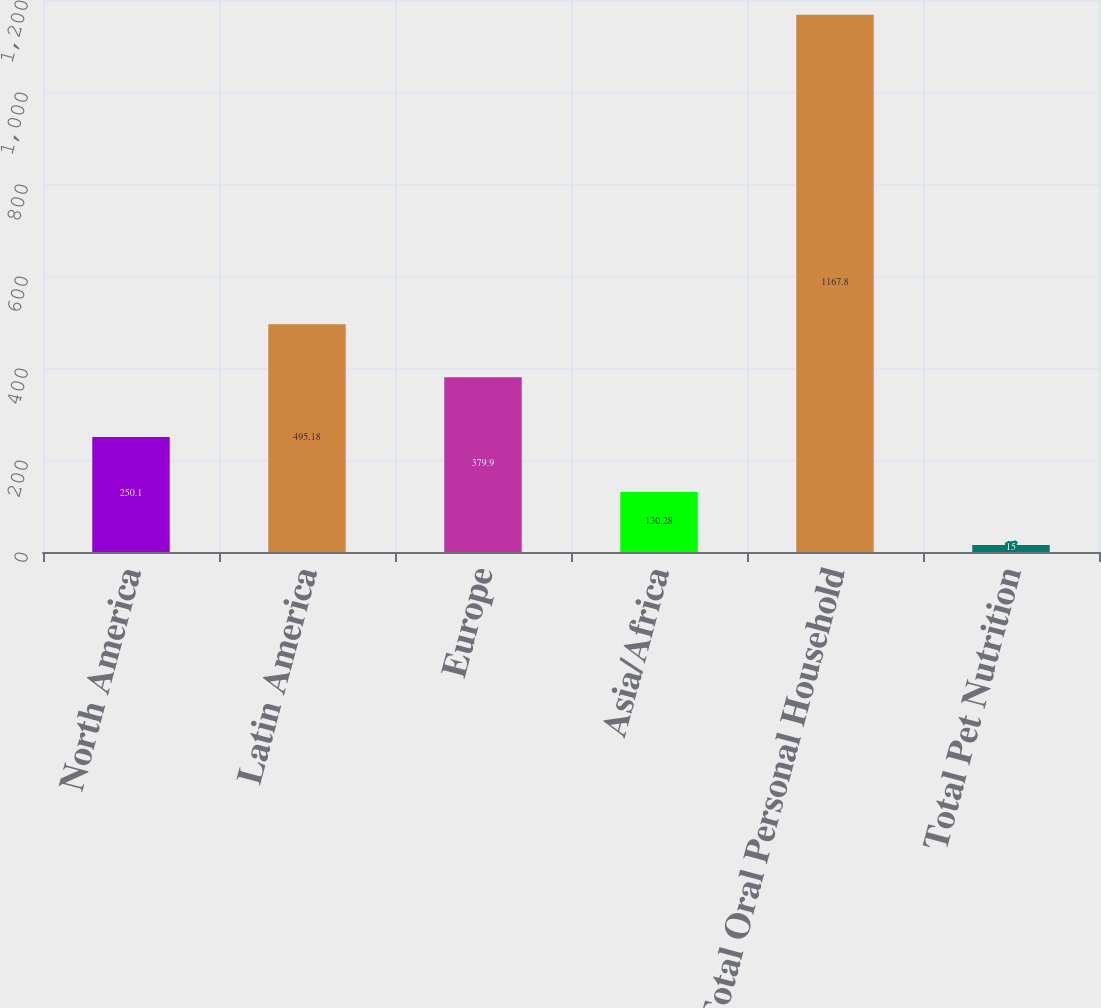Convert chart to OTSL. <chart><loc_0><loc_0><loc_500><loc_500><bar_chart><fcel>North America<fcel>Latin America<fcel>Europe<fcel>Asia/Africa<fcel>Total Oral Personal Household<fcel>Total Pet Nutrition<nl><fcel>250.1<fcel>495.18<fcel>379.9<fcel>130.28<fcel>1167.8<fcel>15<nl></chart> 